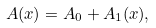<formula> <loc_0><loc_0><loc_500><loc_500>A ( x ) = A _ { 0 } + A _ { 1 } ( x ) ,</formula> 